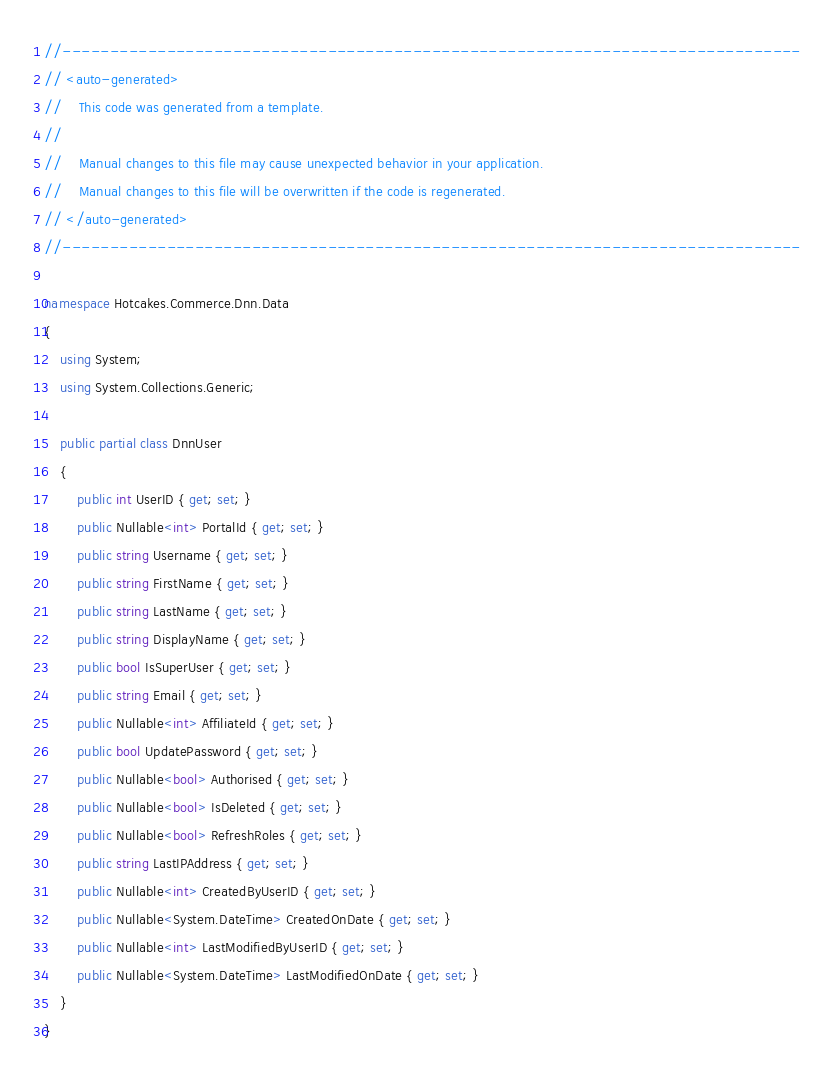Convert code to text. <code><loc_0><loc_0><loc_500><loc_500><_C#_>//------------------------------------------------------------------------------
// <auto-generated>
//    This code was generated from a template.
//
//    Manual changes to this file may cause unexpected behavior in your application.
//    Manual changes to this file will be overwritten if the code is regenerated.
// </auto-generated>
//------------------------------------------------------------------------------

namespace Hotcakes.Commerce.Dnn.Data
{
    using System;
    using System.Collections.Generic;
    
    public partial class DnnUser
    {
        public int UserID { get; set; }
        public Nullable<int> PortalId { get; set; }
        public string Username { get; set; }
        public string FirstName { get; set; }
        public string LastName { get; set; }
        public string DisplayName { get; set; }
        public bool IsSuperUser { get; set; }
        public string Email { get; set; }
        public Nullable<int> AffiliateId { get; set; }
        public bool UpdatePassword { get; set; }
        public Nullable<bool> Authorised { get; set; }
        public Nullable<bool> IsDeleted { get; set; }
        public Nullable<bool> RefreshRoles { get; set; }
        public string LastIPAddress { get; set; }
        public Nullable<int> CreatedByUserID { get; set; }
        public Nullable<System.DateTime> CreatedOnDate { get; set; }
        public Nullable<int> LastModifiedByUserID { get; set; }
        public Nullable<System.DateTime> LastModifiedOnDate { get; set; }
    }
}
</code> 